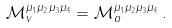Convert formula to latex. <formula><loc_0><loc_0><loc_500><loc_500>\mathcal { M } _ { v } ^ { \mu _ { 1 } \mu _ { 2 } \mu _ { 3 } \mu _ { 4 } } = \mathcal { M } _ { a } ^ { \mu _ { 1 } \mu _ { 2 } \mu _ { 3 } \mu _ { 4 } } \, .</formula> 